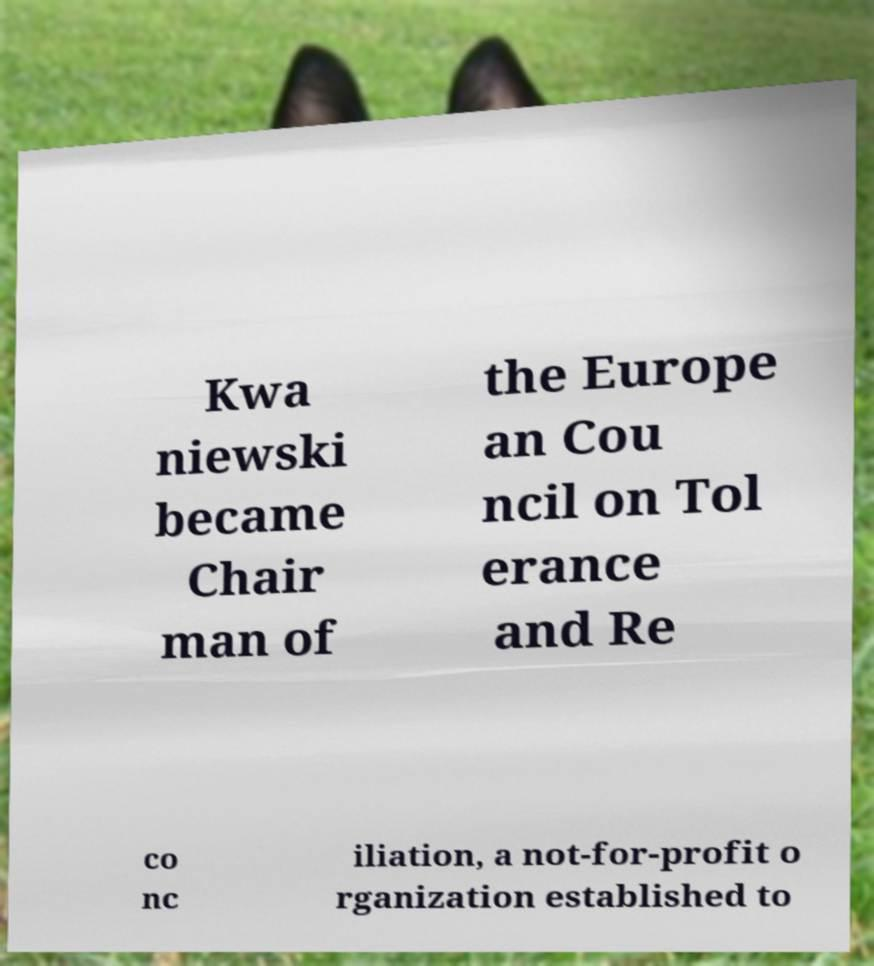Could you extract and type out the text from this image? Kwa niewski became Chair man of the Europe an Cou ncil on Tol erance and Re co nc iliation, a not-for-profit o rganization established to 